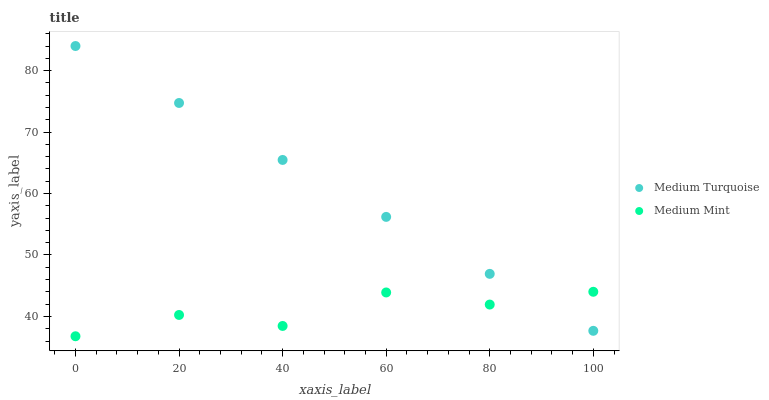Does Medium Mint have the minimum area under the curve?
Answer yes or no. Yes. Does Medium Turquoise have the maximum area under the curve?
Answer yes or no. Yes. Does Medium Turquoise have the minimum area under the curve?
Answer yes or no. No. Is Medium Turquoise the smoothest?
Answer yes or no. Yes. Is Medium Mint the roughest?
Answer yes or no. Yes. Is Medium Turquoise the roughest?
Answer yes or no. No. Does Medium Mint have the lowest value?
Answer yes or no. Yes. Does Medium Turquoise have the lowest value?
Answer yes or no. No. Does Medium Turquoise have the highest value?
Answer yes or no. Yes. Does Medium Turquoise intersect Medium Mint?
Answer yes or no. Yes. Is Medium Turquoise less than Medium Mint?
Answer yes or no. No. Is Medium Turquoise greater than Medium Mint?
Answer yes or no. No. 